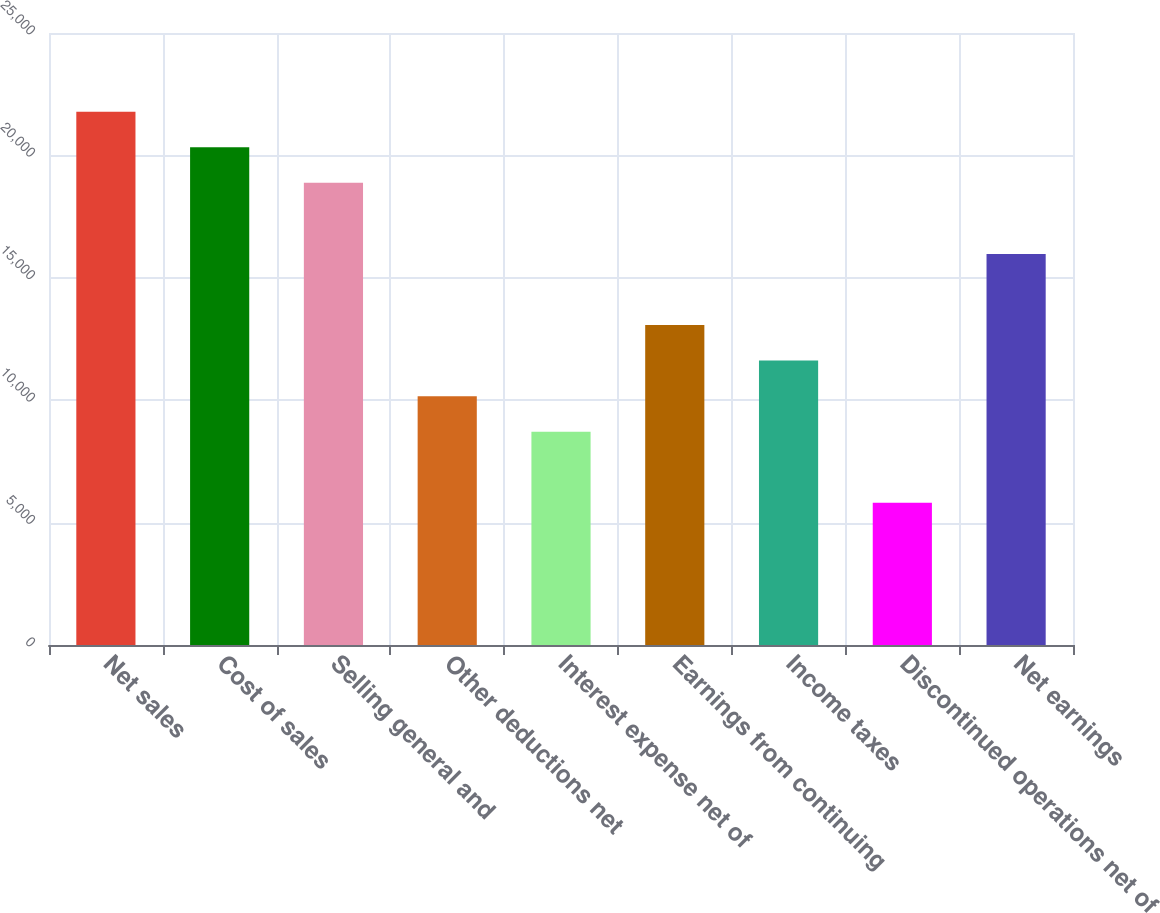Convert chart to OTSL. <chart><loc_0><loc_0><loc_500><loc_500><bar_chart><fcel>Net sales<fcel>Cost of sales<fcel>Selling general and<fcel>Other deductions net<fcel>Interest expense net of<fcel>Earnings from continuing<fcel>Income taxes<fcel>Discontinued operations net of<fcel>Net earnings<nl><fcel>21782.9<fcel>20330.7<fcel>18878.5<fcel>10165.4<fcel>8713.21<fcel>13069.8<fcel>11617.6<fcel>5808.83<fcel>15974.2<nl></chart> 